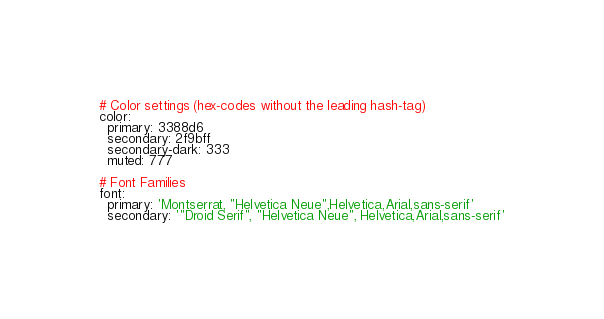<code> <loc_0><loc_0><loc_500><loc_500><_YAML_># Color settings (hex-codes without the leading hash-tag)
color:
  primary: 3388d6
  secondary: 2f9bff   
  secondary-dark: 333
  muted: 777

# Font Families
font:
  primary: 'Montserrat, "Helvetica Neue",Helvetica,Arial,sans-serif'
  secondary: '"Droid Serif", "Helvetica Neue", Helvetica,Arial,sans-serif'
</code> 